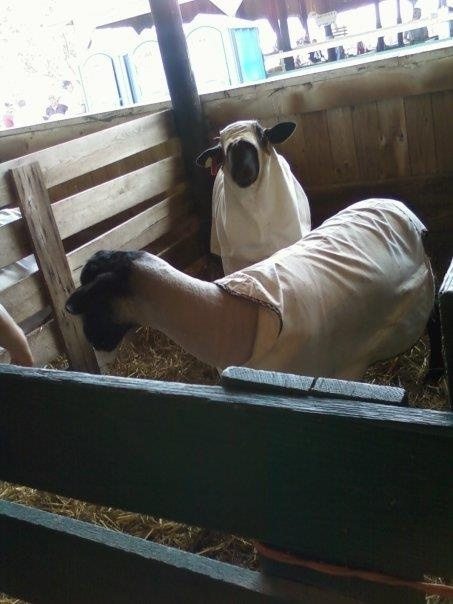Describe the objects in this image and their specific colors. I can see sheep in white, gray, black, lightgray, and darkgray tones, sheep in white, black, maroon, and gray tones, and sheep in white, gray, and black tones in this image. 